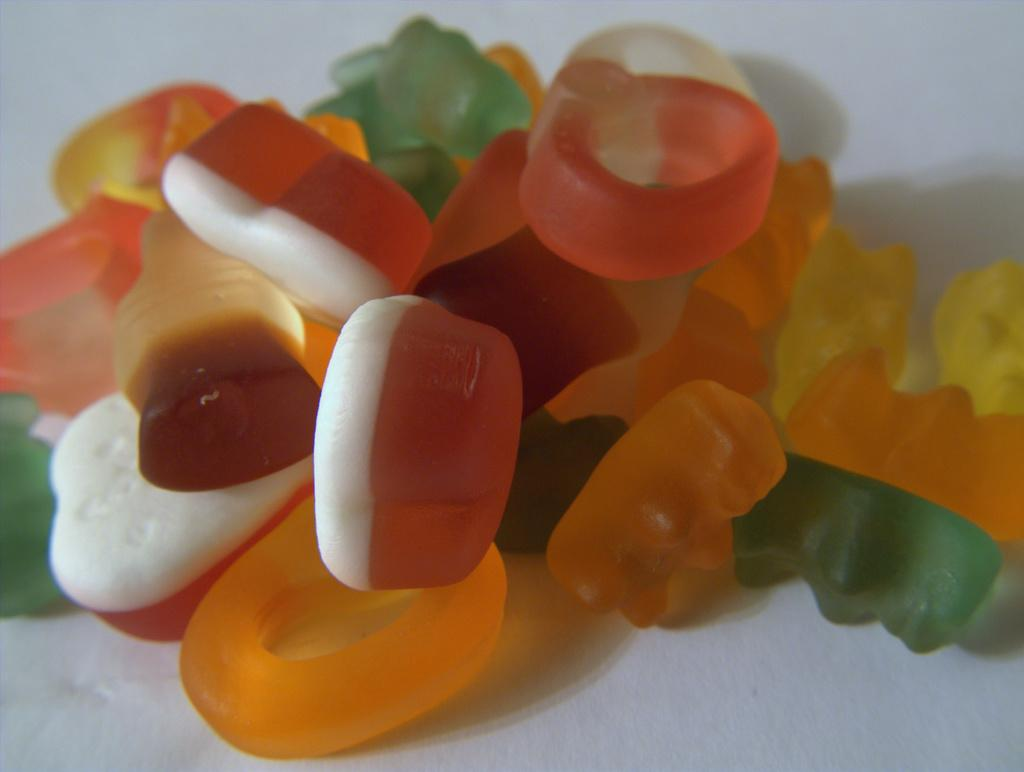What type of candies are visible in the image? There are gummy candies in the image. What color is the surface on which the candies are placed? The gummy candies are on a white surface. Reasoning: Let's think step by identifying the main subject in the image, which is the gummy candies. Then, we expand the conversation to include the color of the surface on which the candies are placed. Each question is designed to elicit a specific detail about the image that is known from the provided facts. Absurd Question/Answer: How many girls are taking care of the cactus in the image? There are no girls or cactus present in the image. How many girls are taking care of the cactus in the image? There are no girls or cactus present in the image. 